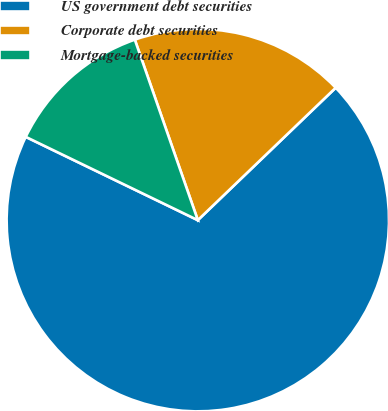Convert chart. <chart><loc_0><loc_0><loc_500><loc_500><pie_chart><fcel>US government debt securities<fcel>Corporate debt securities<fcel>Mortgage-backed securities<nl><fcel>69.36%<fcel>18.17%<fcel>12.48%<nl></chart> 